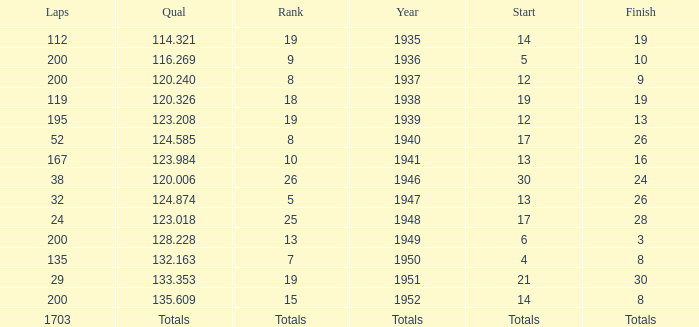Would you be able to parse every entry in this table? {'header': ['Laps', 'Qual', 'Rank', 'Year', 'Start', 'Finish'], 'rows': [['112', '114.321', '19', '1935', '14', '19'], ['200', '116.269', '9', '1936', '5', '10'], ['200', '120.240', '8', '1937', '12', '9'], ['119', '120.326', '18', '1938', '19', '19'], ['195', '123.208', '19', '1939', '12', '13'], ['52', '124.585', '8', '1940', '17', '26'], ['167', '123.984', '10', '1941', '13', '16'], ['38', '120.006', '26', '1946', '30', '24'], ['32', '124.874', '5', '1947', '13', '26'], ['24', '123.018', '25', '1948', '17', '28'], ['200', '128.228', '13', '1949', '6', '3'], ['135', '132.163', '7', '1950', '4', '8'], ['29', '133.353', '19', '1951', '21', '30'], ['200', '135.609', '15', '1952', '14', '8'], ['1703', 'Totals', 'Totals', 'Totals', 'Totals', 'Totals']]} In 1937, what was the finish? 9.0. 